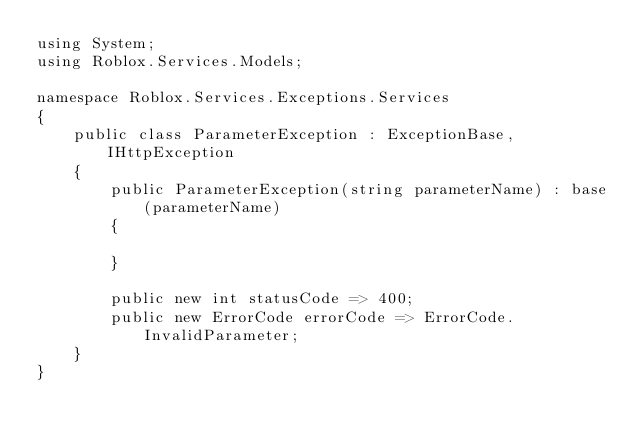Convert code to text. <code><loc_0><loc_0><loc_500><loc_500><_C#_>using System;
using Roblox.Services.Models;

namespace Roblox.Services.Exceptions.Services
{
    public class ParameterException : ExceptionBase, IHttpException
    {
        public ParameterException(string parameterName) : base(parameterName)
        {
            
        }

        public new int statusCode => 400;
        public new ErrorCode errorCode => ErrorCode.InvalidParameter;
    }
}</code> 